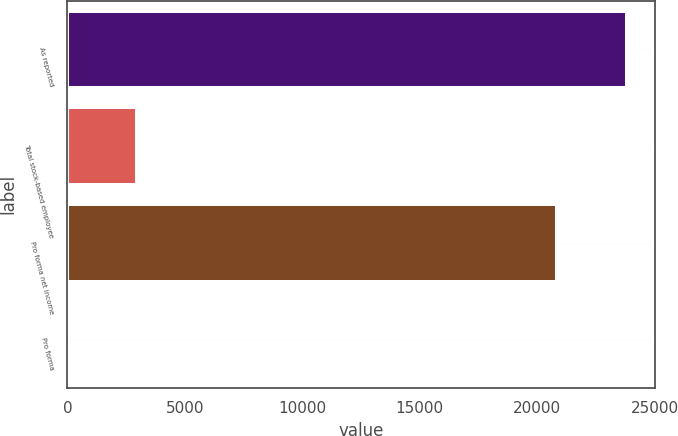<chart> <loc_0><loc_0><loc_500><loc_500><bar_chart><fcel>As reported<fcel>Total stock-based employee<fcel>Pro forma net income<fcel>Pro forma<nl><fcel>23840<fcel>2987<fcel>20853<fcel>0.57<nl></chart> 